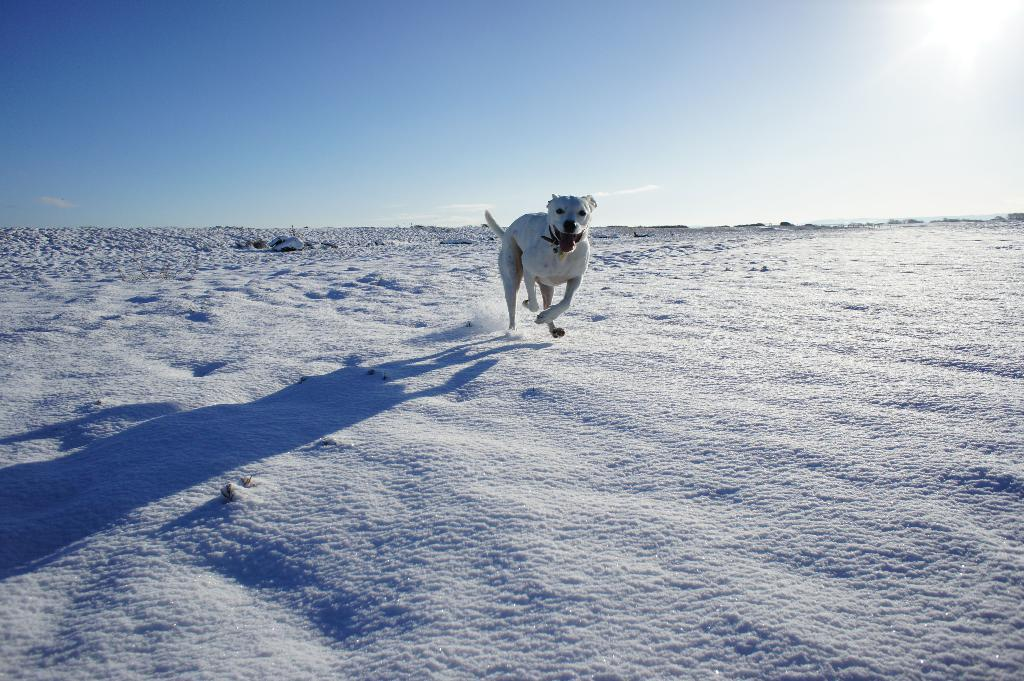What type of animal can be seen in the image? There is a dog in the image. Where is the dog located? The dog is on the ground. What is covering the ground in the image? The ground is covered with snow. What can be seen in the sky in the image? The sky appears cloudy, and the sun is visible. What type of cake is being served to the dog in the image? There is no cake present in the image; it features a dog standing on snowy ground. How does the dog provide support to the payment system in the image? There is no payment system or support provided by the dog in the image; it is simply standing on the ground. 